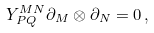Convert formula to latex. <formula><loc_0><loc_0><loc_500><loc_500>Y ^ { M N } _ { P Q } \partial _ { M } \otimes \partial _ { N } = 0 \, ,</formula> 